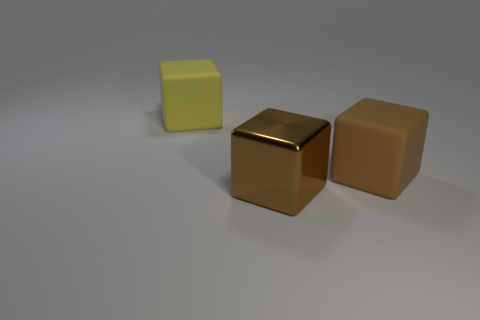Is the number of large metal things that are left of the big yellow matte cube greater than the number of yellow blocks that are in front of the big shiny thing?
Ensure brevity in your answer.  No. There is a object that is both behind the metallic block and to the left of the brown rubber cube; what is its size?
Offer a very short reply. Large. How many yellow matte objects have the same size as the brown metallic block?
Offer a very short reply. 1. There is another thing that is the same color as the big metal object; what is its material?
Give a very brief answer. Rubber. There is a big thing right of the big brown metallic cube; does it have the same shape as the yellow thing?
Keep it short and to the point. Yes. Are there fewer large brown metal blocks that are right of the big metal block than big red metallic cubes?
Your answer should be compact. No. Is there another metal object of the same color as the big metal thing?
Provide a short and direct response. No. There is a brown rubber object; is it the same shape as the object that is to the left of the shiny thing?
Your answer should be very brief. Yes. Are there any yellow cylinders made of the same material as the large yellow block?
Offer a terse response. No. Are there any big brown shiny things in front of the large rubber block behind the brown cube behind the brown metal block?
Offer a terse response. Yes. 